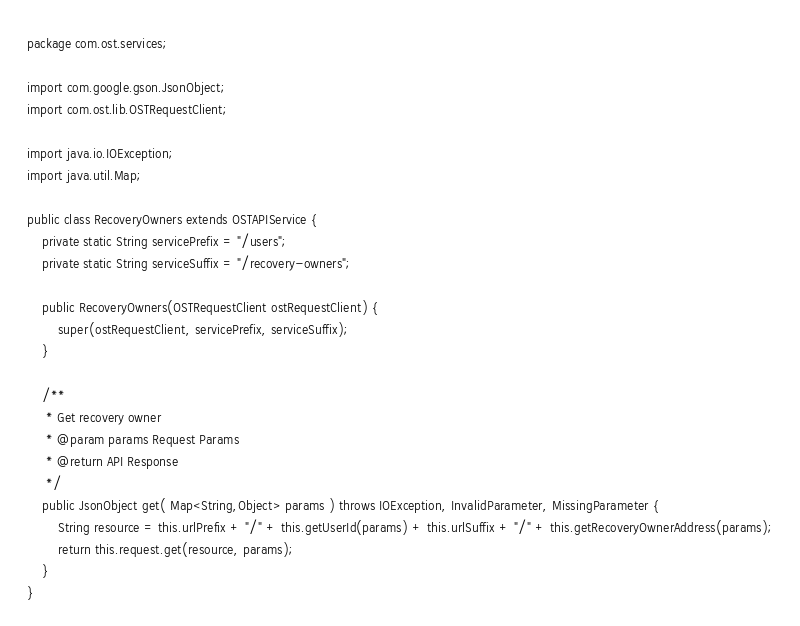<code> <loc_0><loc_0><loc_500><loc_500><_Java_>package com.ost.services;

import com.google.gson.JsonObject;
import com.ost.lib.OSTRequestClient;

import java.io.IOException;
import java.util.Map;

public class RecoveryOwners extends OSTAPIService {
    private static String servicePrefix = "/users";
    private static String serviceSuffix = "/recovery-owners";

    public RecoveryOwners(OSTRequestClient ostRequestClient) {
        super(ostRequestClient, servicePrefix, serviceSuffix);
    }

    /**
     * Get recovery owner
     * @param params Request Params
     * @return API Response
     */
    public JsonObject get( Map<String,Object> params ) throws IOException, InvalidParameter, MissingParameter {
        String resource = this.urlPrefix + "/" + this.getUserId(params) + this.urlSuffix + "/" + this.getRecoveryOwnerAddress(params);
        return this.request.get(resource, params);
    }
}

</code> 